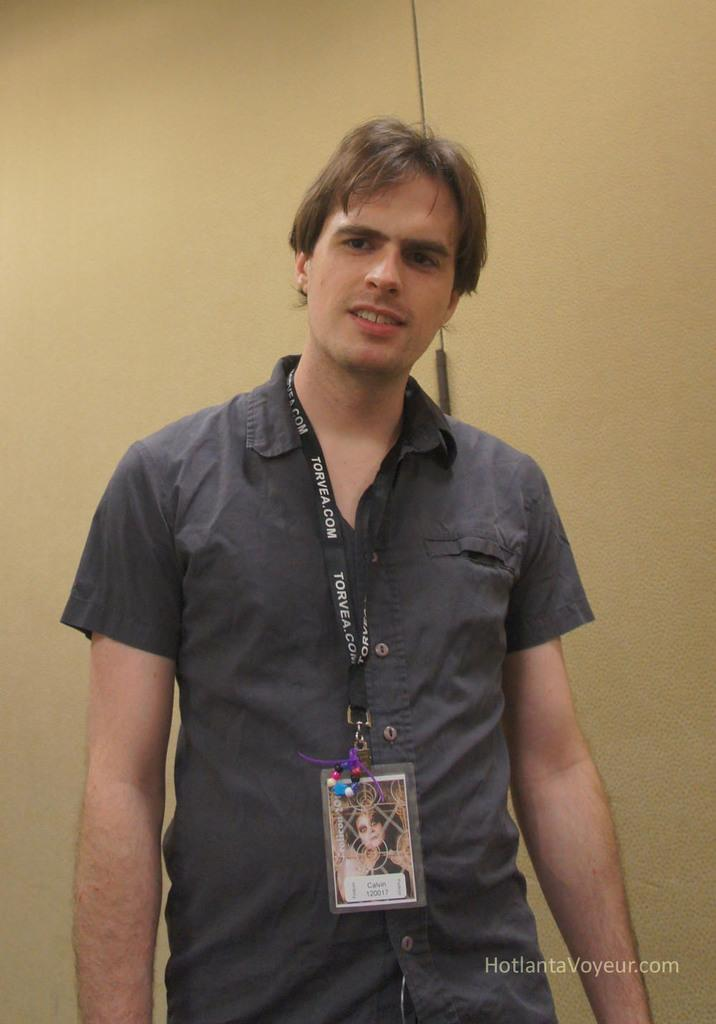What is the main subject of the image? There is a man standing in the image. What object can be seen near the man? There is a wire tag in the image. What color is the background of the image? The background of the image is cream-colored. Where is the text located in the image? The text is visible in the bottom right side of the image. What type of fuel is being used by the man in the image? There is no indication of any fuel being used in the image, as it features a man standing and a wire tag. Can you describe the bite marks on the man's arm in the image? There are no bite marks visible on the man's arm in the image. 